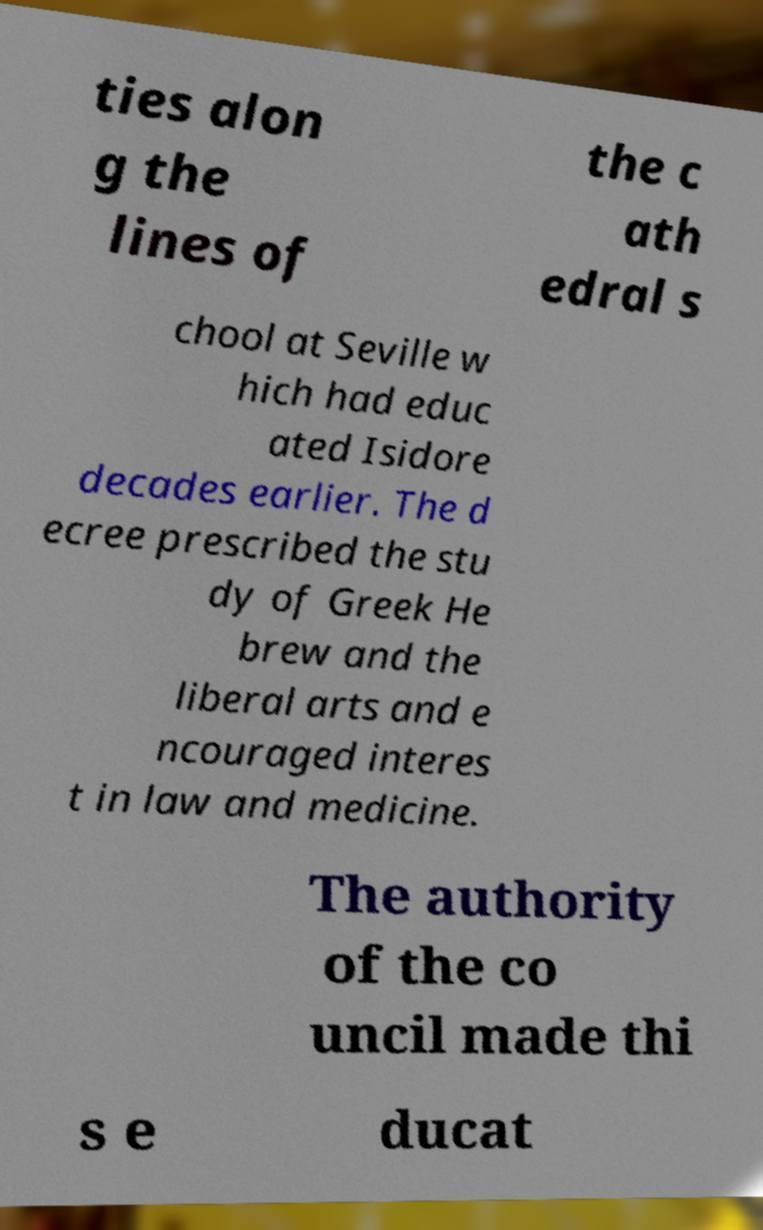I need the written content from this picture converted into text. Can you do that? ties alon g the lines of the c ath edral s chool at Seville w hich had educ ated Isidore decades earlier. The d ecree prescribed the stu dy of Greek He brew and the liberal arts and e ncouraged interes t in law and medicine. The authority of the co uncil made thi s e ducat 